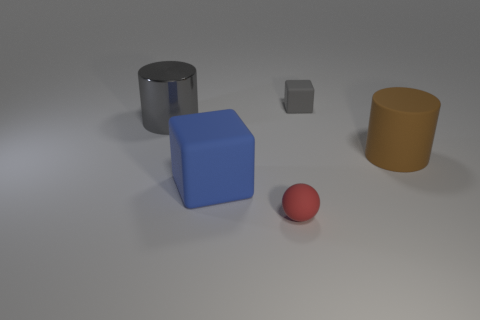What is the size of the gray object that is the same shape as the blue thing?
Provide a succinct answer. Small. There is a tiny thing that is behind the big blue cube; is it the same shape as the tiny red matte thing?
Make the answer very short. No. There is a cube that is in front of the big rubber object right of the small red matte object; what color is it?
Offer a very short reply. Blue. Is the number of blue rubber cubes less than the number of small brown blocks?
Keep it short and to the point. No. Are there any objects that have the same material as the tiny red ball?
Offer a very short reply. Yes. There is a brown thing; does it have the same shape as the gray object on the right side of the matte ball?
Your response must be concise. No. There is a blue thing; are there any metallic cylinders left of it?
Offer a terse response. Yes. What number of big matte objects have the same shape as the tiny gray object?
Your answer should be compact. 1. Are the small red object and the big cylinder that is on the right side of the blue matte thing made of the same material?
Offer a terse response. Yes. What number of metal things are there?
Keep it short and to the point. 1. 